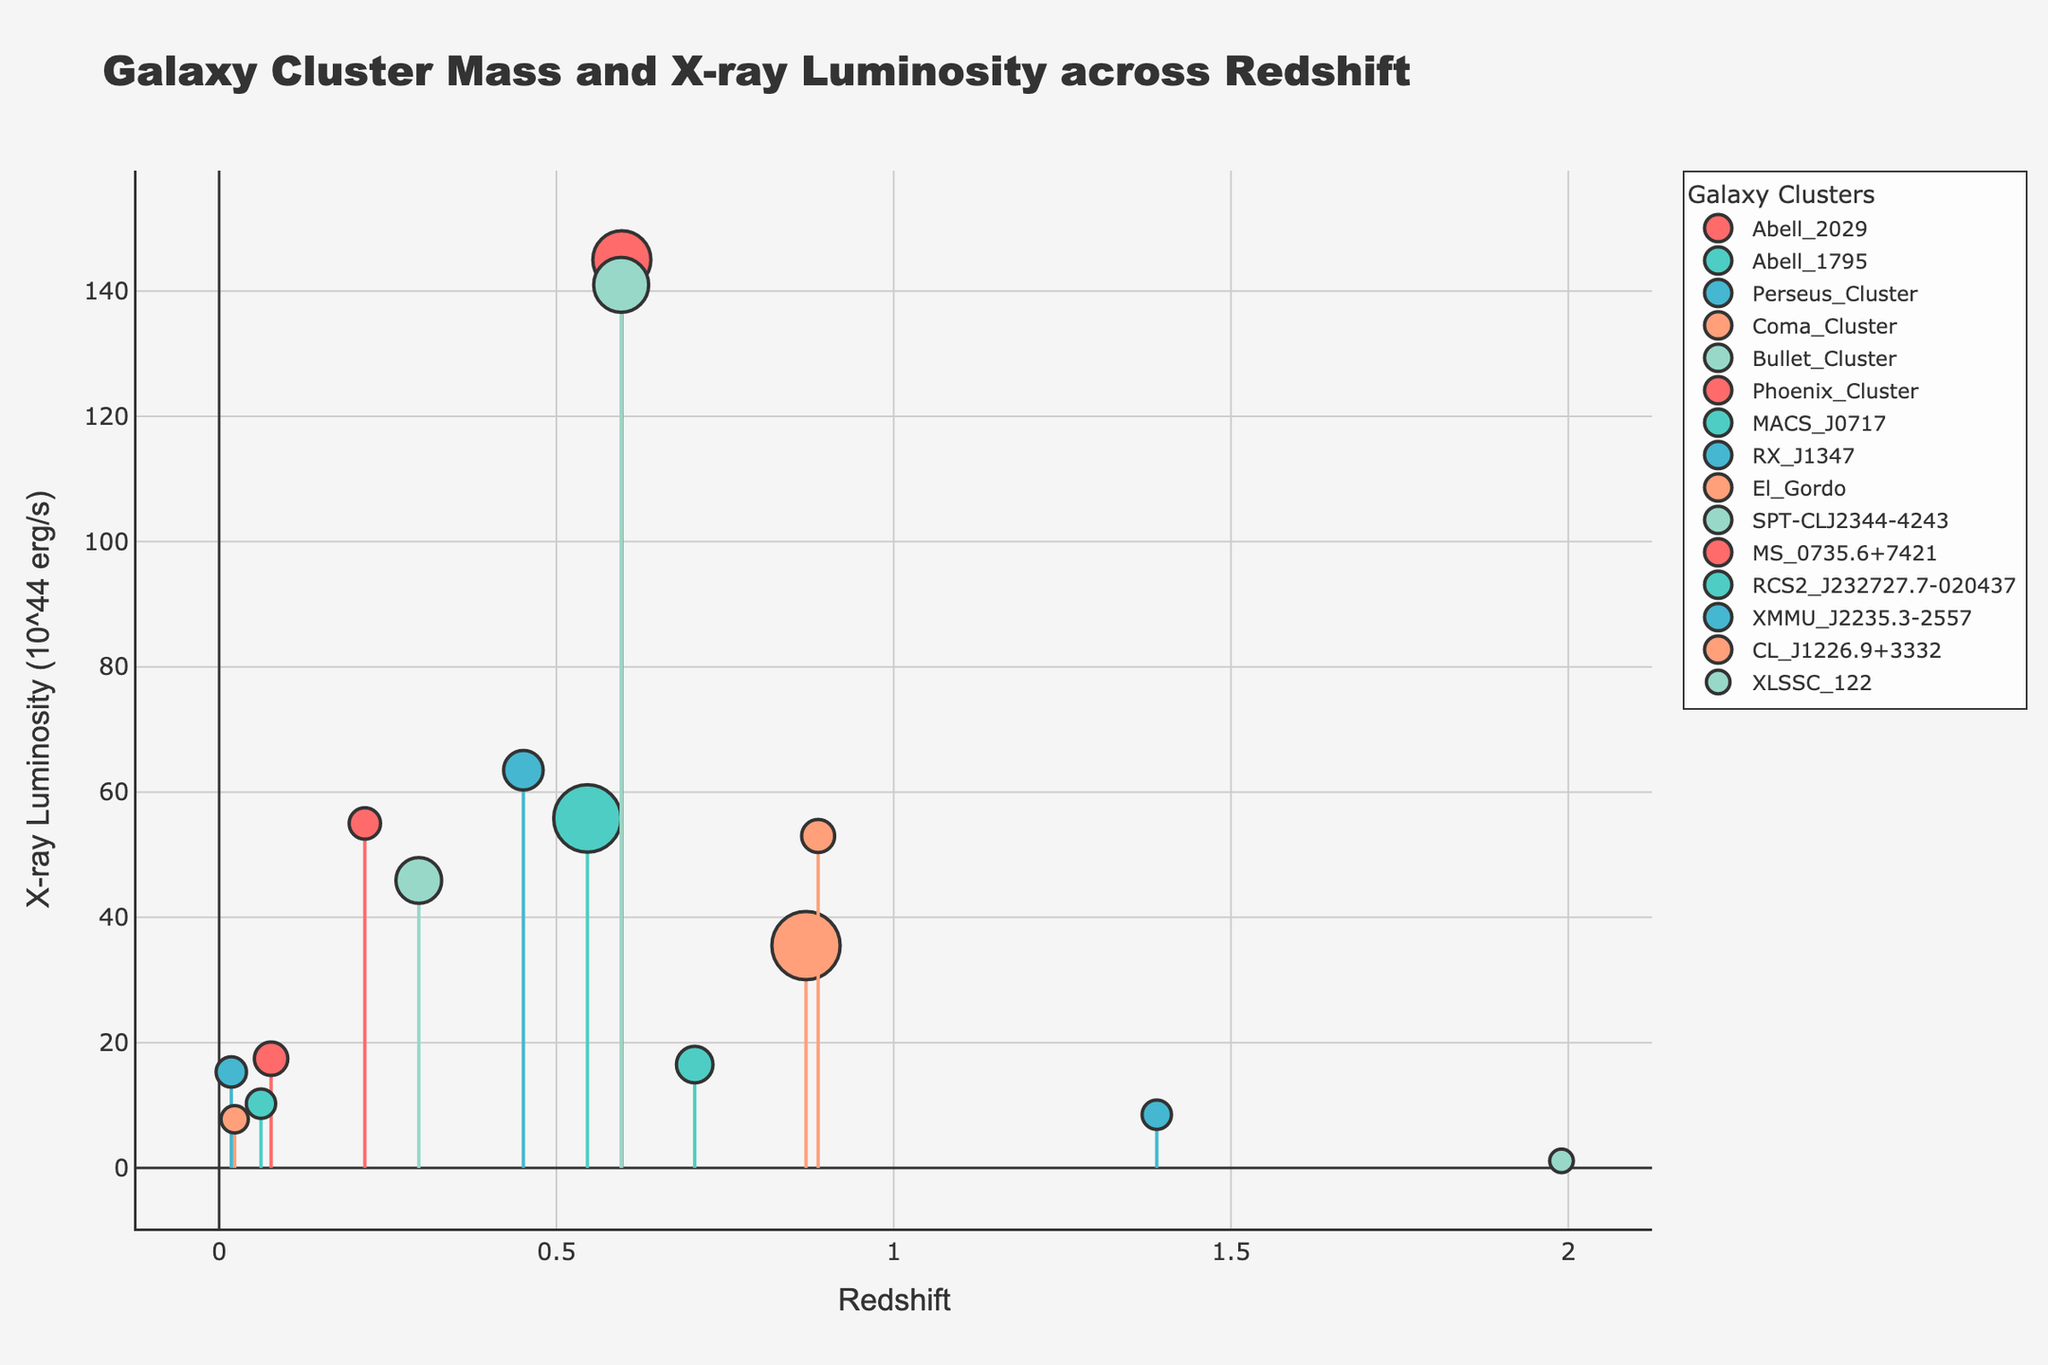What is the title of the plot? The title is displayed at the top of the plot and provides a summary of the data being presented. It reads "Galaxy Cluster Mass and X-ray Luminosity across Redshift."
Answer: Galaxy Cluster Mass and X-ray Luminosity across Redshift What's the x-axis label on the plot? The x-axis, which represents the horizontal dimension of the plot, is labeled with the term "Redshift." This indicates that redshift values are plotted horizontally.
Answer: Redshift How are the data points differentiated in the plot? The data points are differentiated by color and size. Each galaxy cluster has a unique color, and the marker size is proportional to the mass of the galaxy cluster. Larger masses result in larger marker sizes.
Answer: By color and size Which galaxy cluster has the highest X-ray luminosity and what is its redshift value? To determine the highest X-ray luminosity, scan the y-axis for the highest value and find the associated galaxy cluster. The Phoenix Cluster has the highest X-ray luminosity of 145.00 x 10^44 erg/s at a redshift value of 0.597.
Answer: Phoenix Cluster, 0.597 What is the mass of the Coma Cluster? To find the mass of the Coma Cluster, inspect the data point for this cluster where the mass is labeled as 5.0 x 10^14 Msun.
Answer: 5.0 x 10^14 Msun Which galaxy cluster has the lowest X-ray luminosity and what is its mass? To identify the lowest X-ray luminosity, scan the y-axis for the minimum value. The XLSSC_122 cluster has the lowest X-ray luminosity of 1.13 x 10^44 erg/s and a mass of 3.2 x 10^14 Msun.
Answer: XLSSC_122, 3.2 x 10^14 Msun Compare the X-ray luminosities of the Bullet Cluster and RX J1347. Which one is higher and by how much? To compare, look at the y-axis values for both clusters. The Bullet Cluster has an X-ray luminosity of 45.90 x 10^44 erg/s, and RX J1347 has 63.50 x 10^44 erg/s. Subtracting these gives 63.50 - 45.90 = 17.60.
Answer: RX J1347, 17.60 x 10^44 erg/s What is the range of redshift values represented in the plot? The redshift values range from the minimum to the maximum value on the x-axis. The minimum redshift is 0.018 (Perseus Cluster) and the maximum is 1.990 (XLSSC_122).
Answer: 0.018 to 1.990 Which galaxy cluster has the largest mass and what is its X-ray luminosity? By examining the sizes of the markers or the mass values, the galaxy cluster with the largest mass is the El Gordo with a mass of 25.0 x 10^14 Msun. Its X-ray luminosity is 35.50 x 10^44 erg/s.
Answer: El Gordo, 35.50 x 10^44 erg/s Are there any galaxy clusters with the same redshift but different X-ray luminosities? Inspect the x-axis to see if multiple data points share the same redshift. Both Phoenix Cluster and SPT-CLJ2344-4243 share the redshift of 0.596 but their X-ray luminosities are 145.00 x 10^44 erg/s and 141.00 x 10^44 erg/s respectively.
Answer: Yes, Phoenix Cluster and SPT-CLJ2344-4243 